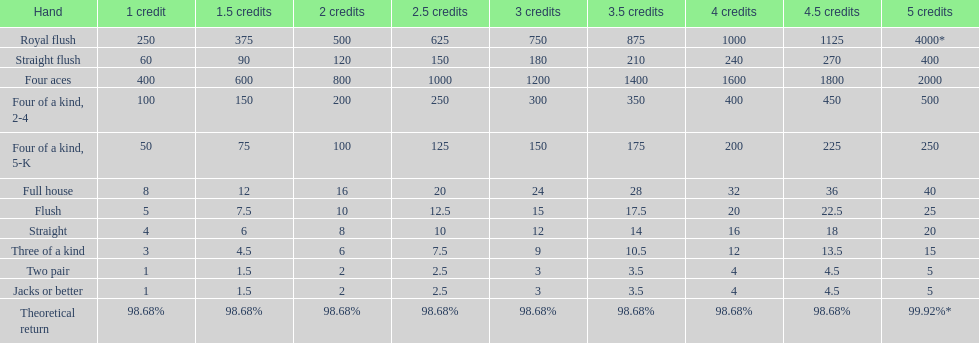The number of credits returned for a one credit bet on a royal flush are. 250. 